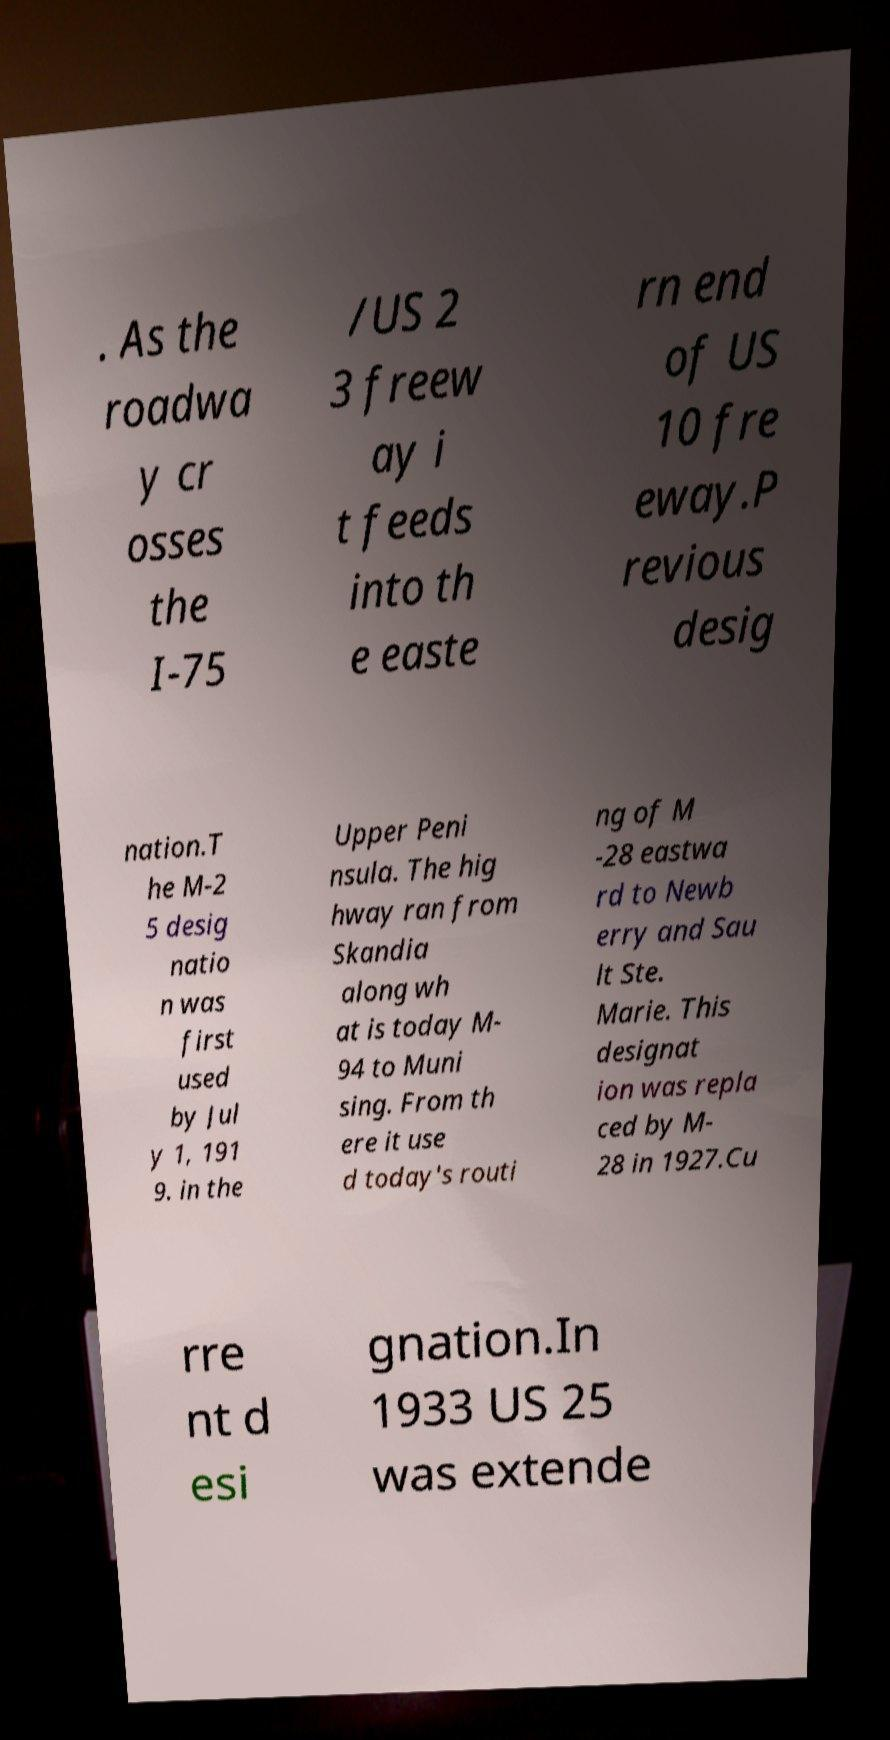I need the written content from this picture converted into text. Can you do that? . As the roadwa y cr osses the I-75 /US 2 3 freew ay i t feeds into th e easte rn end of US 10 fre eway.P revious desig nation.T he M-2 5 desig natio n was first used by Jul y 1, 191 9. in the Upper Peni nsula. The hig hway ran from Skandia along wh at is today M- 94 to Muni sing. From th ere it use d today's routi ng of M -28 eastwa rd to Newb erry and Sau lt Ste. Marie. This designat ion was repla ced by M- 28 in 1927.Cu rre nt d esi gnation.In 1933 US 25 was extende 